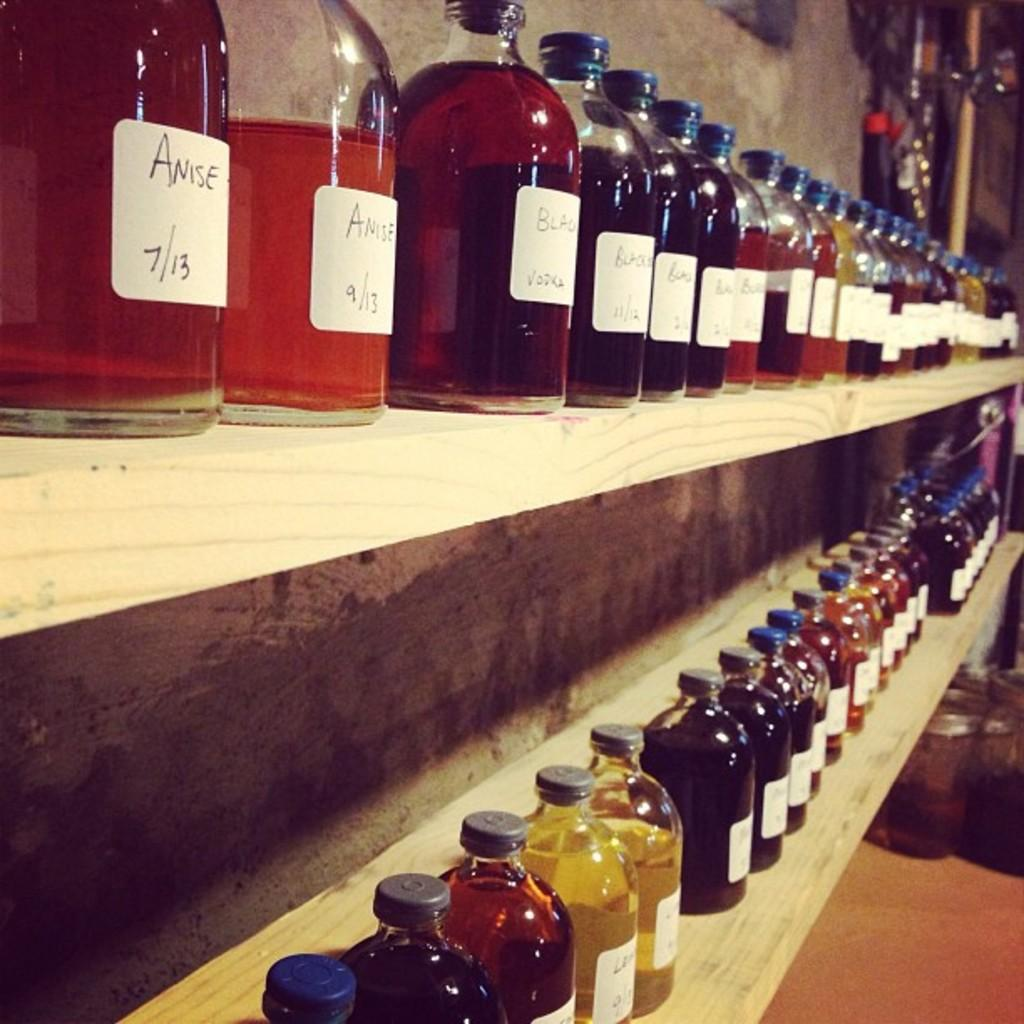What can be seen on the shelves in the image? There are many bottles on the shelves. What is visible in the background of the image? There is a wall in the background of the image. How many frogs are sitting on the bottles in the image? There are no frogs present in the image; it only features bottles on the shelves. What color is the eye of the person in the image? There is no person present in the image, so it is not possible to determine the color of their eye. 